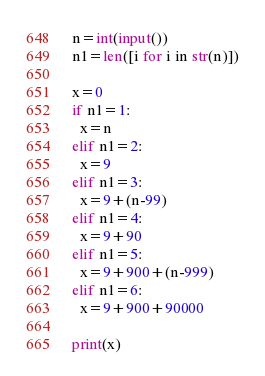<code> <loc_0><loc_0><loc_500><loc_500><_Python_>n=int(input())
n1=len([i for i in str(n)])

x=0
if n1=1:
  x=n
elif n1=2:
  x=9
elif n1=3:
  x=9+(n-99)
elif n1=4:
  x=9+90
elif n1=5:
  x=9+900+(n-999)
elif n1=6:
  x=9+900+90000
  
print(x)</code> 